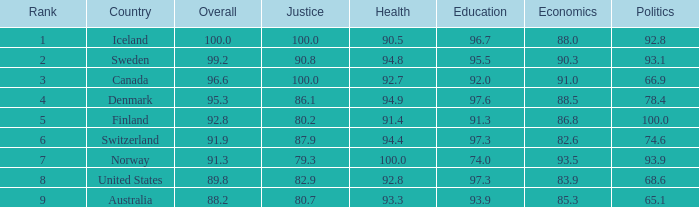What's the country with health being 91.4 Finland. 